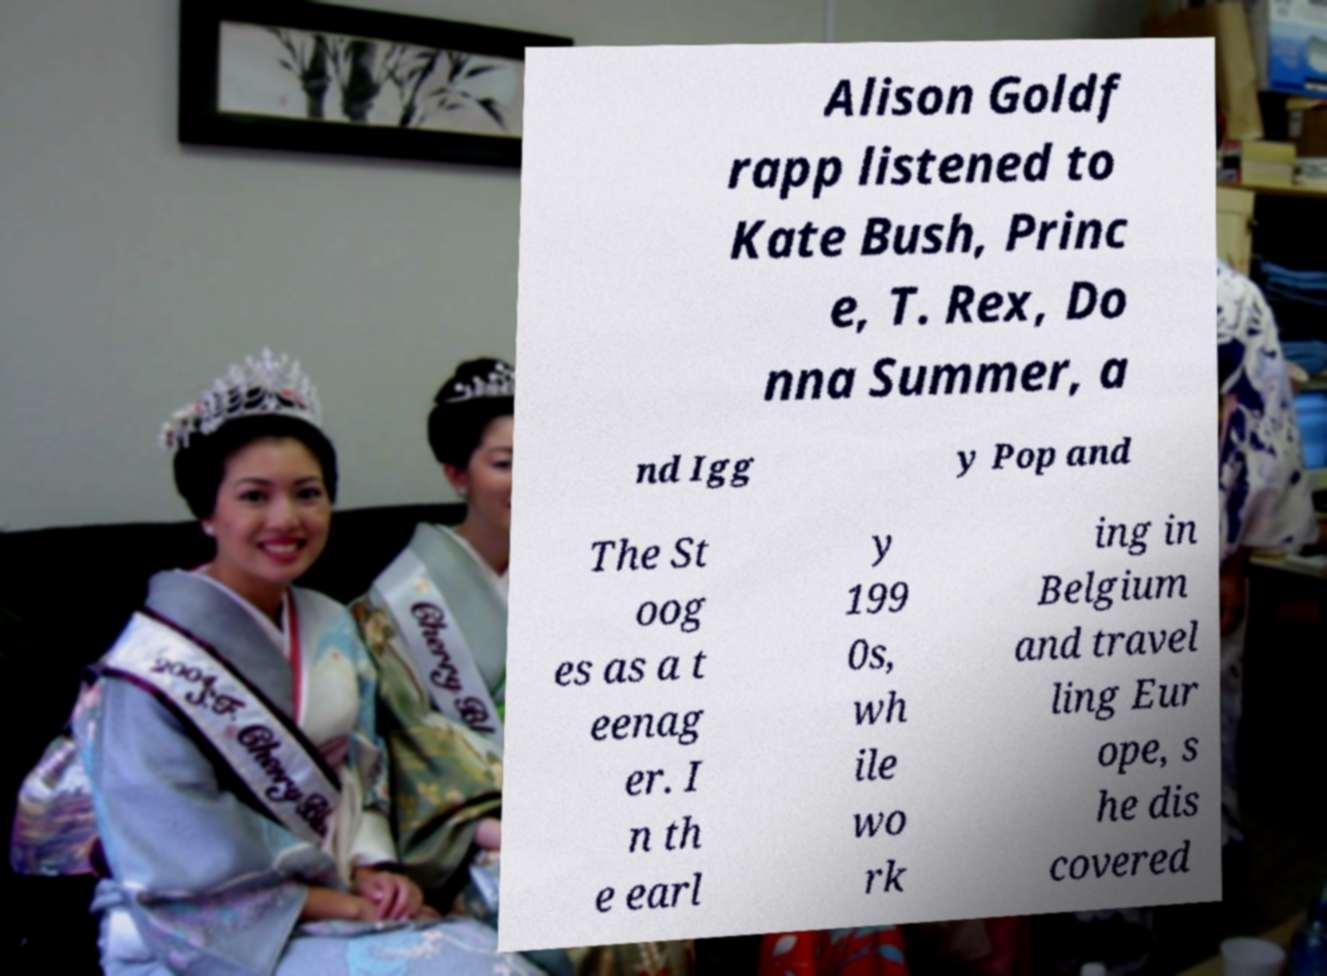There's text embedded in this image that I need extracted. Can you transcribe it verbatim? Alison Goldf rapp listened to Kate Bush, Princ e, T. Rex, Do nna Summer, a nd Igg y Pop and The St oog es as a t eenag er. I n th e earl y 199 0s, wh ile wo rk ing in Belgium and travel ling Eur ope, s he dis covered 